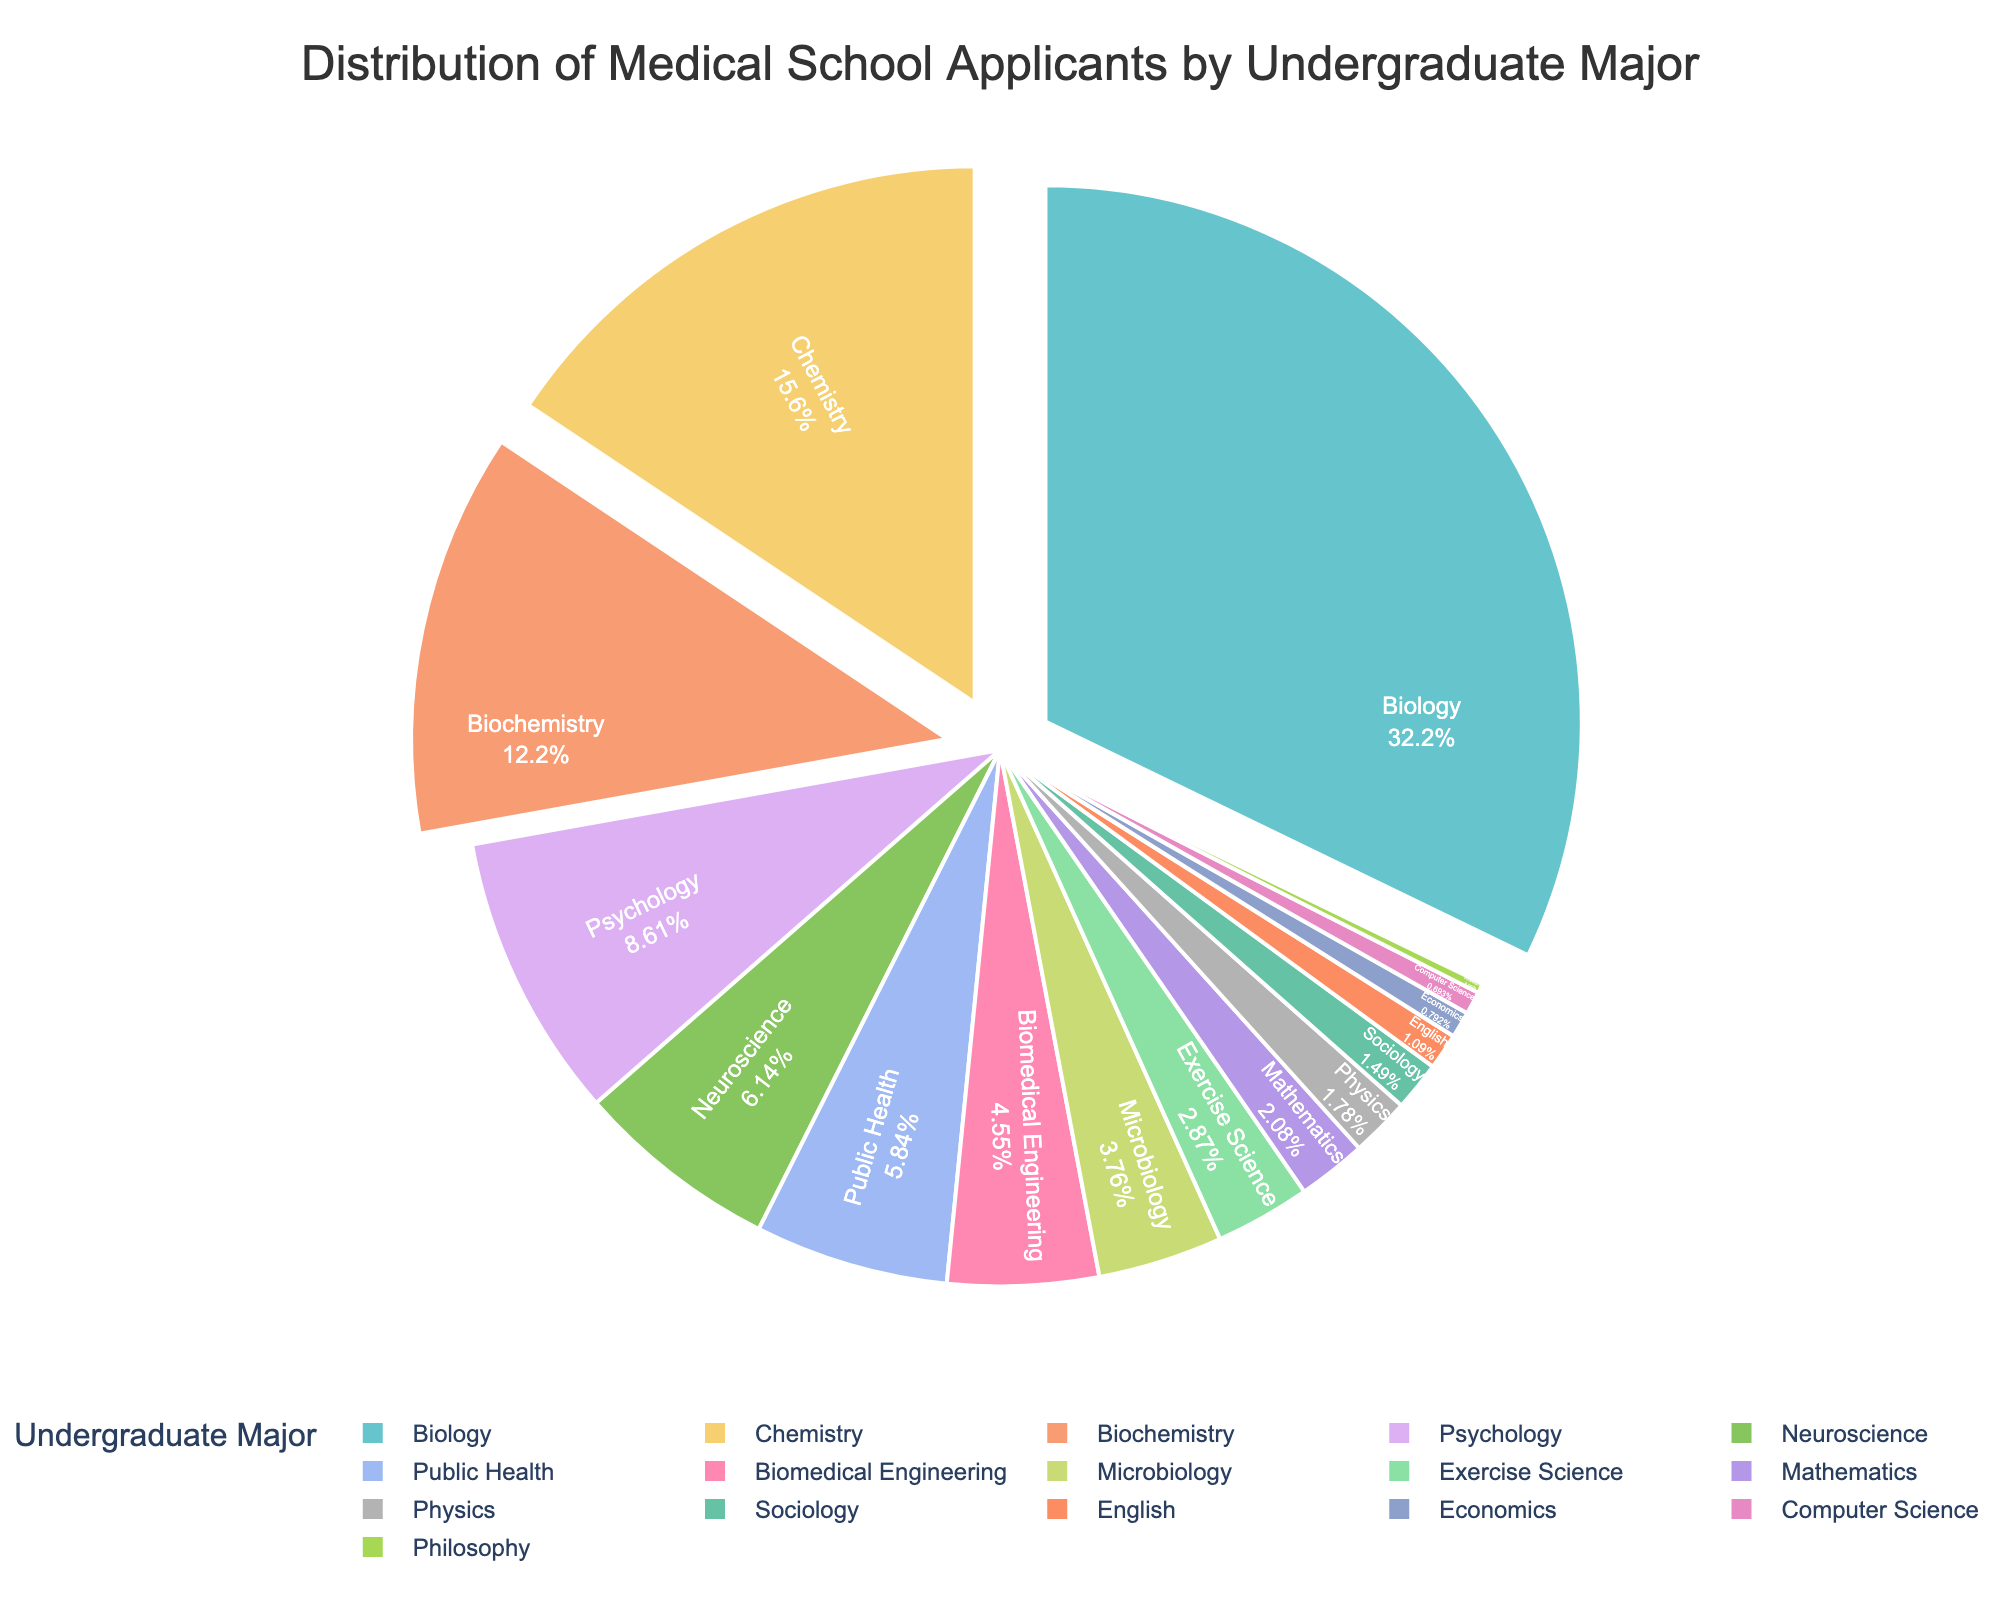What is the most common undergraduate major for medical school applicants? Looking at the largest segment in the pie chart, identify the major with the highest percentage.
Answer: Biology Which major has a higher percentage of applicants, Chemistry or Biochemistry? Compare the size of the slices representing Chemistry and Biochemistry and note the percentages.
Answer: Chemistry What is the combined percentage of applicants from Psychology and Neuroscience majors? Sum the percentages of applicants from the Psychology and Neuroscience majors. 8.7% + 6.2% = 14.9%
Answer: 14.9% Are there more applicants with a major in Public Health or Biomedical Engineering? Compare the sizes of the pie chart segments for Public Health and Biomedical Engineering.
Answer: Public Health Which major has the smallest percentage of applicants, and what is it? Identify the smallest slice in the pie chart and note the percentage.
Answer: Philosophy How does the combined percentage of Microbiology and Exercise Science compare to Biochemistry? First, sum the percentages of Microbiology and Exercise Science (3.8% + 2.9% = 6.7%), then compare it with the percentage of Biochemistry (12.3%).
Answer: Biochemistry is higher What is the percentage difference between Biology and Chemistry applicants? Subtract the percentage of Chemistry from the percentage of Biology. 32.5% - 15.8% = 16.7%
Answer: 16.7% How many majors have less than 2% of the total applicants? Count the number of slices in the pie chart that represent less than 2% each: Physics, Sociology, English, Economics, Computer Science, Philosophy.
Answer: 6 Which major appears in a light color and has a relatively smaller share (less than 1%) of applicants? Look for the light-colored slice with a share smaller than 1%, identifying its major.
Answer: Computer Science How does the percentage of Biomedical Engineering applicants compare with Mathematics and Physics combined? Sum the percentages of Mathematics and Physics (2.1% + 1.8% = 3.9%), then compare with Biomedical Engineering (4.6%).
Answer: Biomedical Engineering is higher 